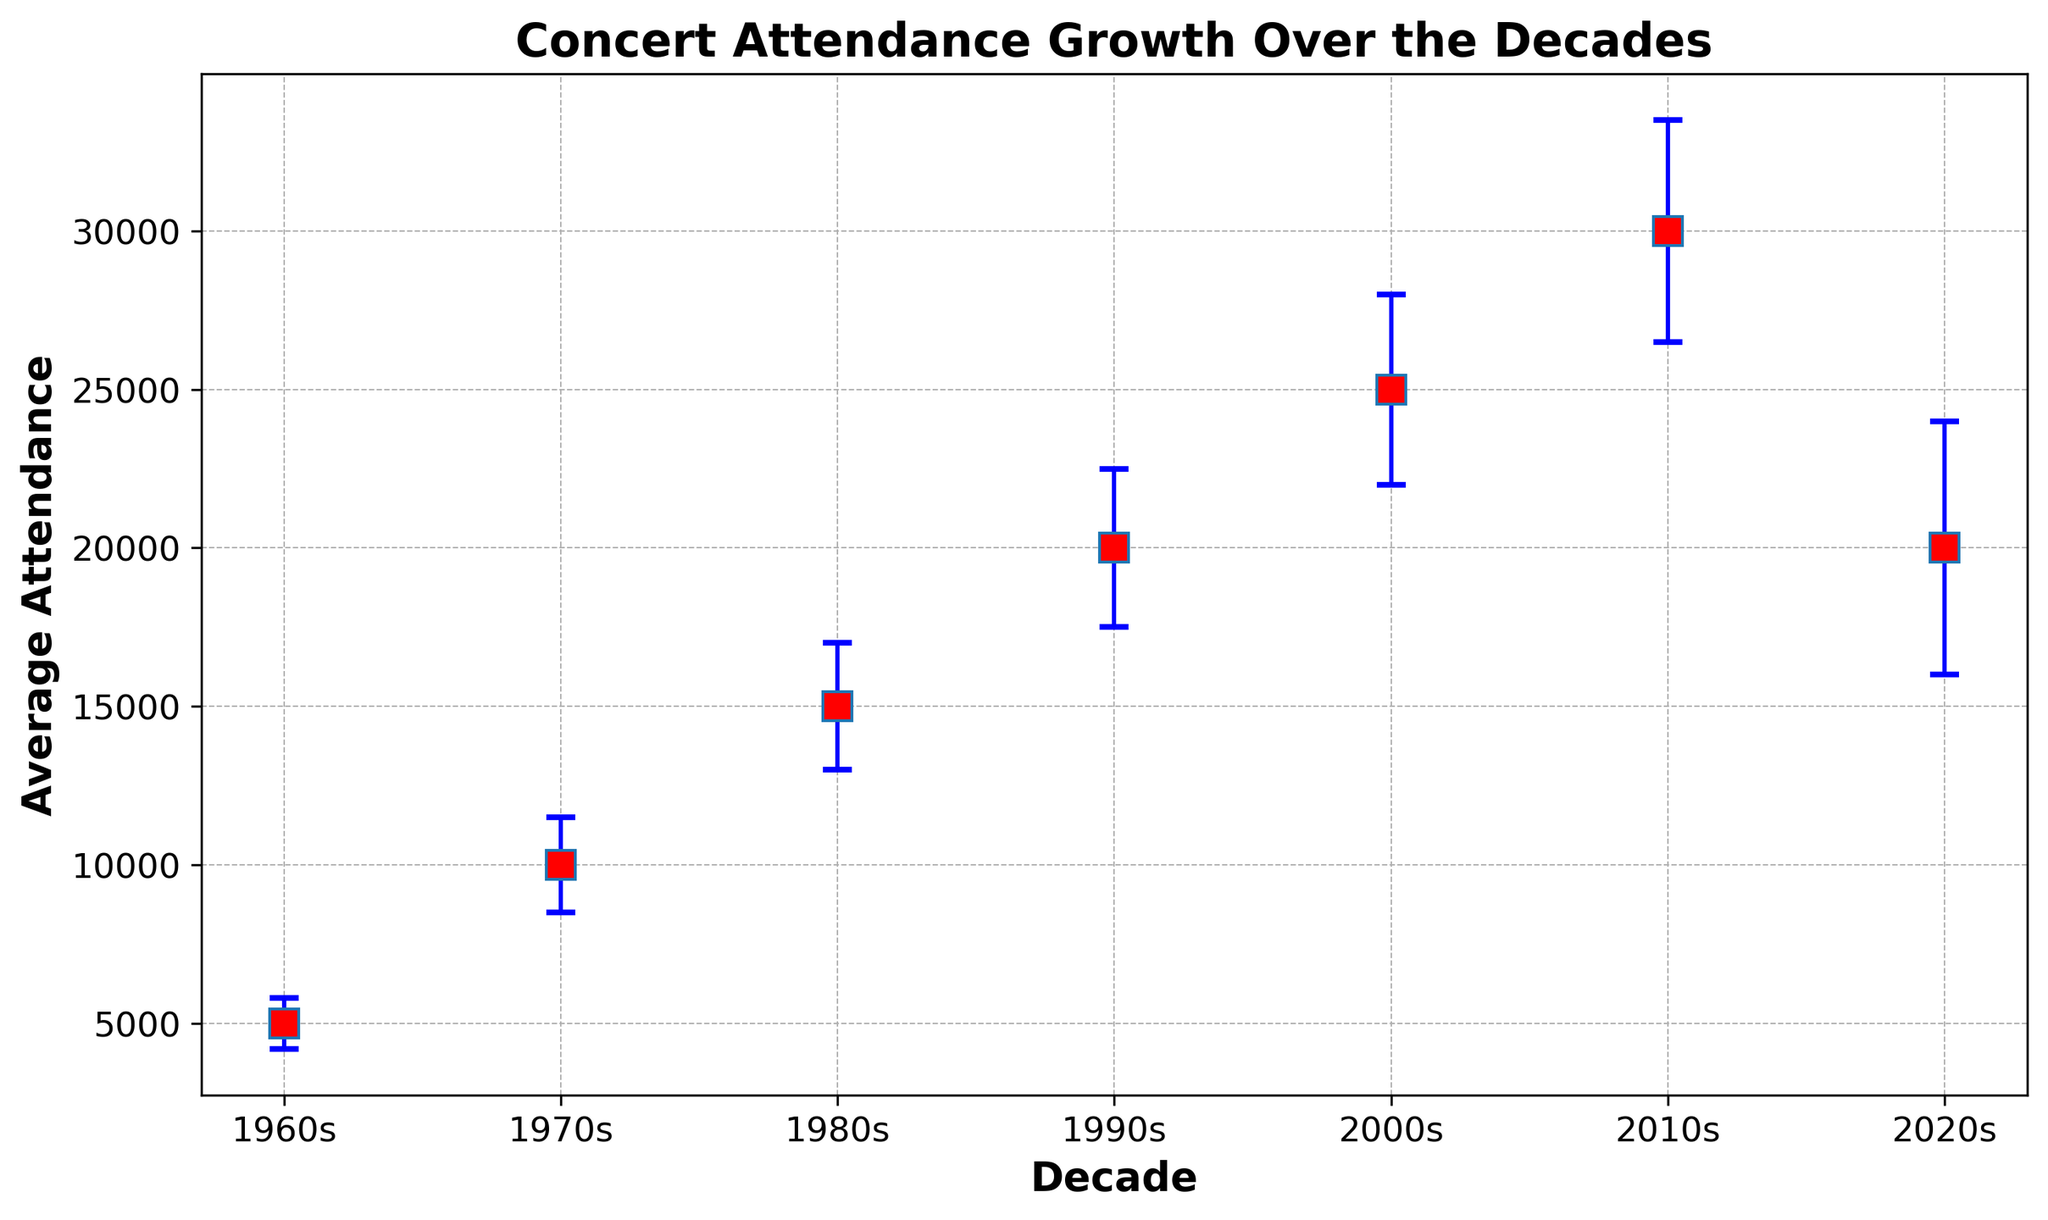How did the average attendance change from the 1960s to the 2010s? To determine the change, we subtract the average attendance in the 1960s from the average attendance in the 2010s. The attendance values are 30000 (2010s) and 5000 (1960s), respectively. Therefore, 30000 - 5000 = 25000.
Answer: 25000 Which decade had the highest average concert attendance? We look at the y-values of the points on the plot for each decade and find the highest value. The highest y-value is 30000, which occurs in the 2010s.
Answer: 2010s How does the variability (standard deviation) in the 2020s compare to the 2000s? We look at the error bars' caps representing the standard deviation. The error bar for the 2020s extends visibly higher than that for the 2000s, indicating higher variability. The standard deviations are 4000 (2020s) and 3000 (2000s). Therefore, 4000 > 3000.
Answer: The variability is higher in the 2020s What is the average concert attendance in the 1980s? We directly read the value of the y-coordinate for the point labeled '1980s', which is 15000.
Answer: 15000 By how much did the variability (standard deviation) increase from the 1960s to the 1990s? Given the standard deviation values, we subtract the 1960s value (800) from the 1990s value (2500). Therefore, 2500 - 800 = 1700.
Answer: 1700 How do the average attendances of the 1970s and the 2020s compare? The average values for the 1970s and 2020s are 10000 and 20000, respectively. Since 20000 > 10000, the 2020s had a higher average attendance.
Answer: The attendance in the 2020s is higher Which decades have overlapping error bars? We identify which decades have error bars that intersect. The range of attendance for the 1980s (15000 ± 2000) is 13000 to 17000, and the range for the 1990s (20000 ± 2500) is 17500 to 22500, so they do not overlap. However, the ranges for 2000s (25000 ± 3000) and 2010s (30000 ± 3500) overlap between 22000 and 32000.
Answer: 2000s and 2010s What is the sum of average attendances for the 1960s and 1970s? We add the average attendances for the 1960s (5000) and the 1970s (10000). Therefore, 5000 + 10000 = 15000.
Answer: 15000 